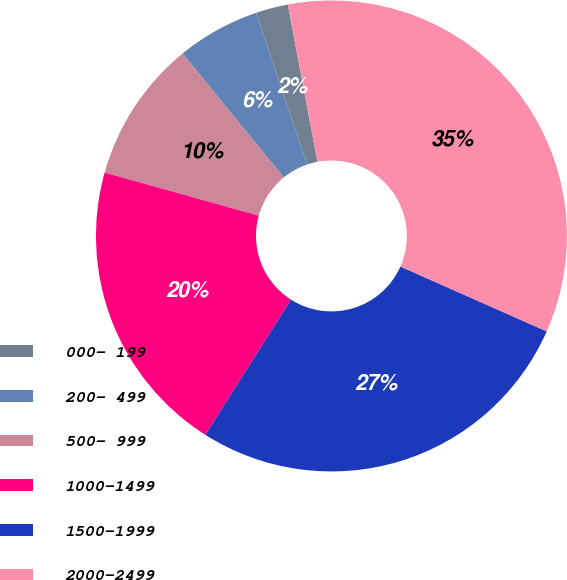Convert chart to OTSL. <chart><loc_0><loc_0><loc_500><loc_500><pie_chart><fcel>000- 199<fcel>200- 499<fcel>500- 999<fcel>1000-1499<fcel>1500-1999<fcel>2000-2499<nl><fcel>2.22%<fcel>5.71%<fcel>9.77%<fcel>20.34%<fcel>27.36%<fcel>34.61%<nl></chart> 